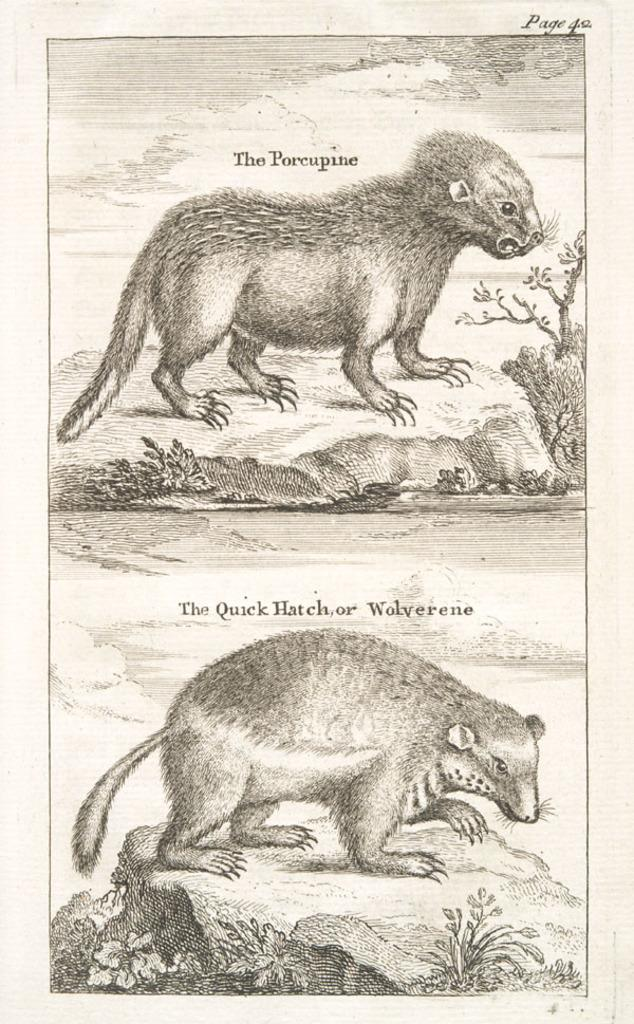What is the main subject of the image? There is a picture in the image. What can be seen in the picture? The picture contains two animals. Where is the lake located in the image? There is no lake present in the image; it only contains a picture with two animals. 